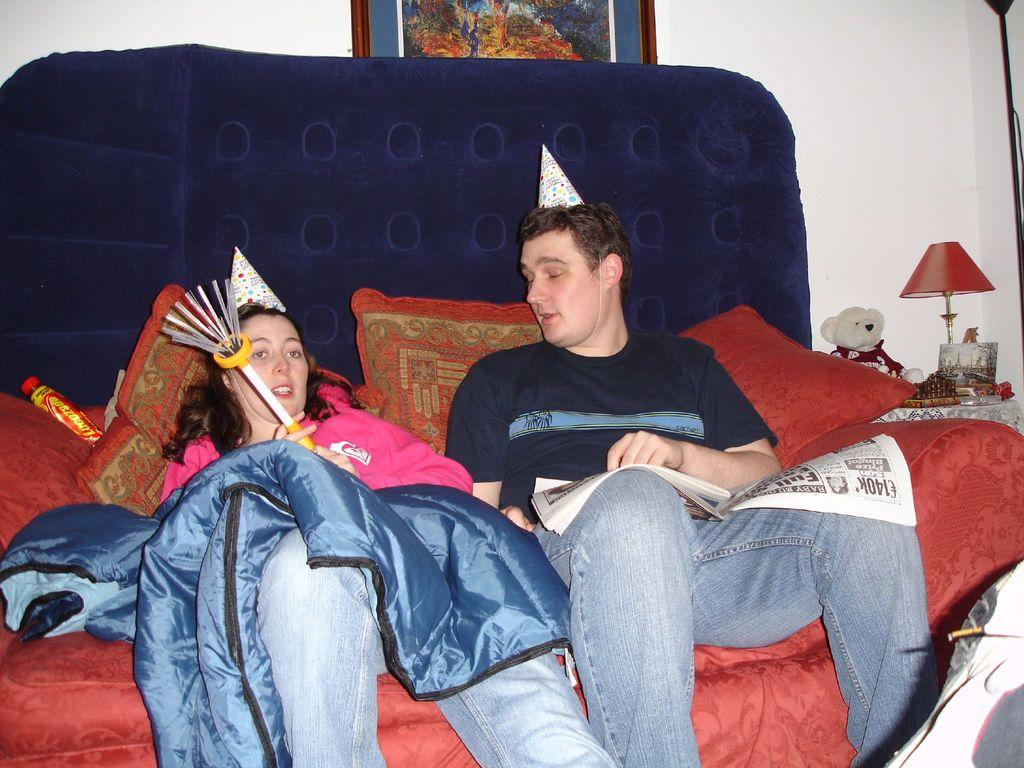How many people are in the image? There are two persons in the image. What are the persons wearing on their heads? The persons are wearing caps. Where are the persons sitting in the image? The persons are sitting on a sofa. What can be seen on the right side of the image? There is a lamp on the right side of the image. What is located at the top of the image? There is a photo frame at the top of the image. Are the persons in the image reading any books? There is no indication in the image that the persons are reading any books. Can you see a door in the image? There is no door visible in the image. 